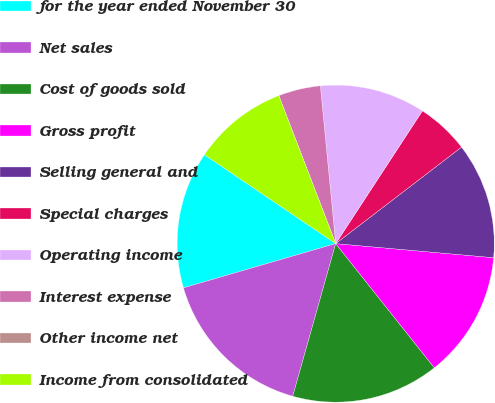Convert chart. <chart><loc_0><loc_0><loc_500><loc_500><pie_chart><fcel>for the year ended November 30<fcel>Net sales<fcel>Cost of goods sold<fcel>Gross profit<fcel>Selling general and<fcel>Special charges<fcel>Operating income<fcel>Interest expense<fcel>Other income net<fcel>Income from consolidated<nl><fcel>13.98%<fcel>16.13%<fcel>15.05%<fcel>12.9%<fcel>11.83%<fcel>5.38%<fcel>10.75%<fcel>4.3%<fcel>0.0%<fcel>9.68%<nl></chart> 